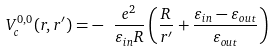<formula> <loc_0><loc_0><loc_500><loc_500>V _ { c } ^ { 0 , 0 } ( { r } , { r } ^ { \prime } ) = - \text { } \frac { e ^ { 2 } } { \varepsilon _ { i n } R } \left ( \frac { R } { r ^ { \prime } } + \frac { \varepsilon _ { i n } - \varepsilon _ { o u t } } { \varepsilon _ { o u t } } \right )</formula> 